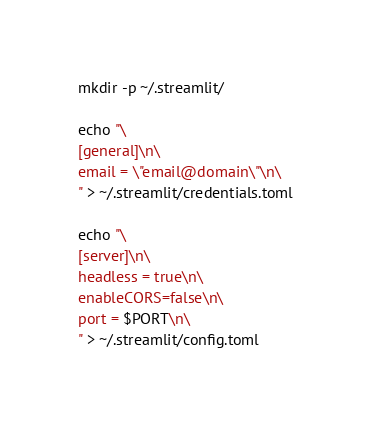<code> <loc_0><loc_0><loc_500><loc_500><_Bash_>mkdir -p ~/.streamlit/

echo "\
[general]\n\
email = \"email@domain\"\n\
" > ~/.streamlit/credentials.toml

echo "\
[server]\n\
headless = true\n\
enableCORS=false\n\
port = $PORT\n\
" > ~/.streamlit/config.toml</code> 